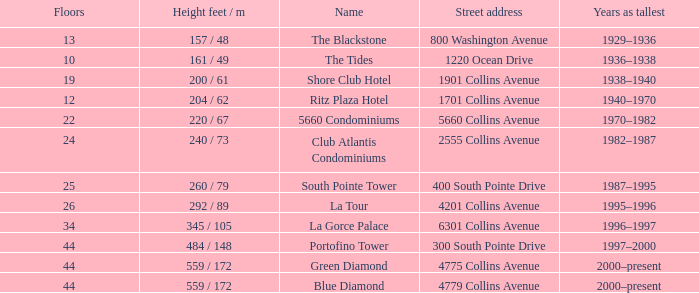How many floors does the Blue Diamond have? 44.0. 